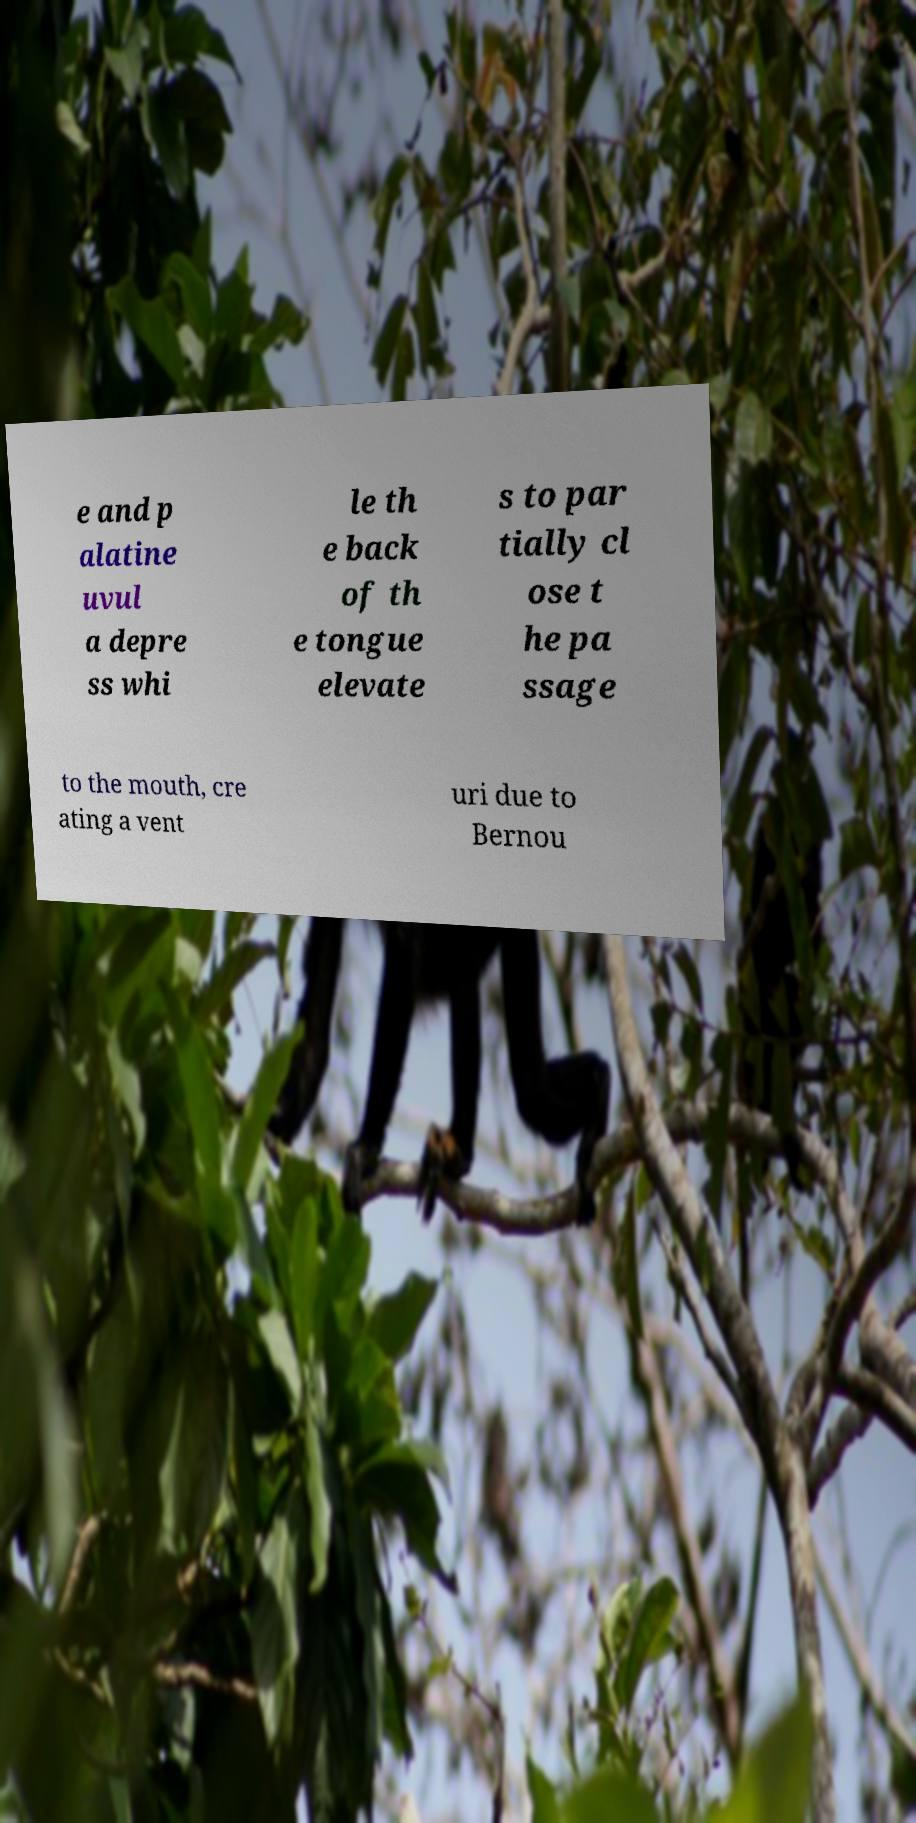I need the written content from this picture converted into text. Can you do that? e and p alatine uvul a depre ss whi le th e back of th e tongue elevate s to par tially cl ose t he pa ssage to the mouth, cre ating a vent uri due to Bernou 